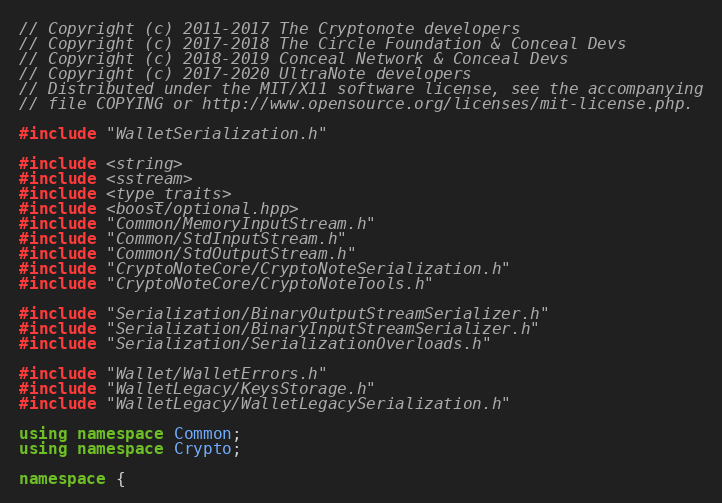Convert code to text. <code><loc_0><loc_0><loc_500><loc_500><_C++_>// Copyright (c) 2011-2017 The Cryptonote developers
// Copyright (c) 2017-2018 The Circle Foundation & Conceal Devs
// Copyright (c) 2018-2019 Conceal Network & Conceal Devs
// Copyright (c) 2017-2020 UltraNote developers
// Distributed under the MIT/X11 software license, see the accompanying
// file COPYING or http://www.opensource.org/licenses/mit-license.php.

#include "WalletSerialization.h"

#include <string>
#include <sstream>
#include <type_traits>
#include <boost/optional.hpp>
#include "Common/MemoryInputStream.h"
#include "Common/StdInputStream.h"
#include "Common/StdOutputStream.h"
#include "CryptoNoteCore/CryptoNoteSerialization.h"
#include "CryptoNoteCore/CryptoNoteTools.h"

#include "Serialization/BinaryOutputStreamSerializer.h"
#include "Serialization/BinaryInputStreamSerializer.h"
#include "Serialization/SerializationOverloads.h"

#include "Wallet/WalletErrors.h"
#include "WalletLegacy/KeysStorage.h"
#include "WalletLegacy/WalletLegacySerialization.h"

using namespace Common;
using namespace Crypto;

namespace {
</code> 